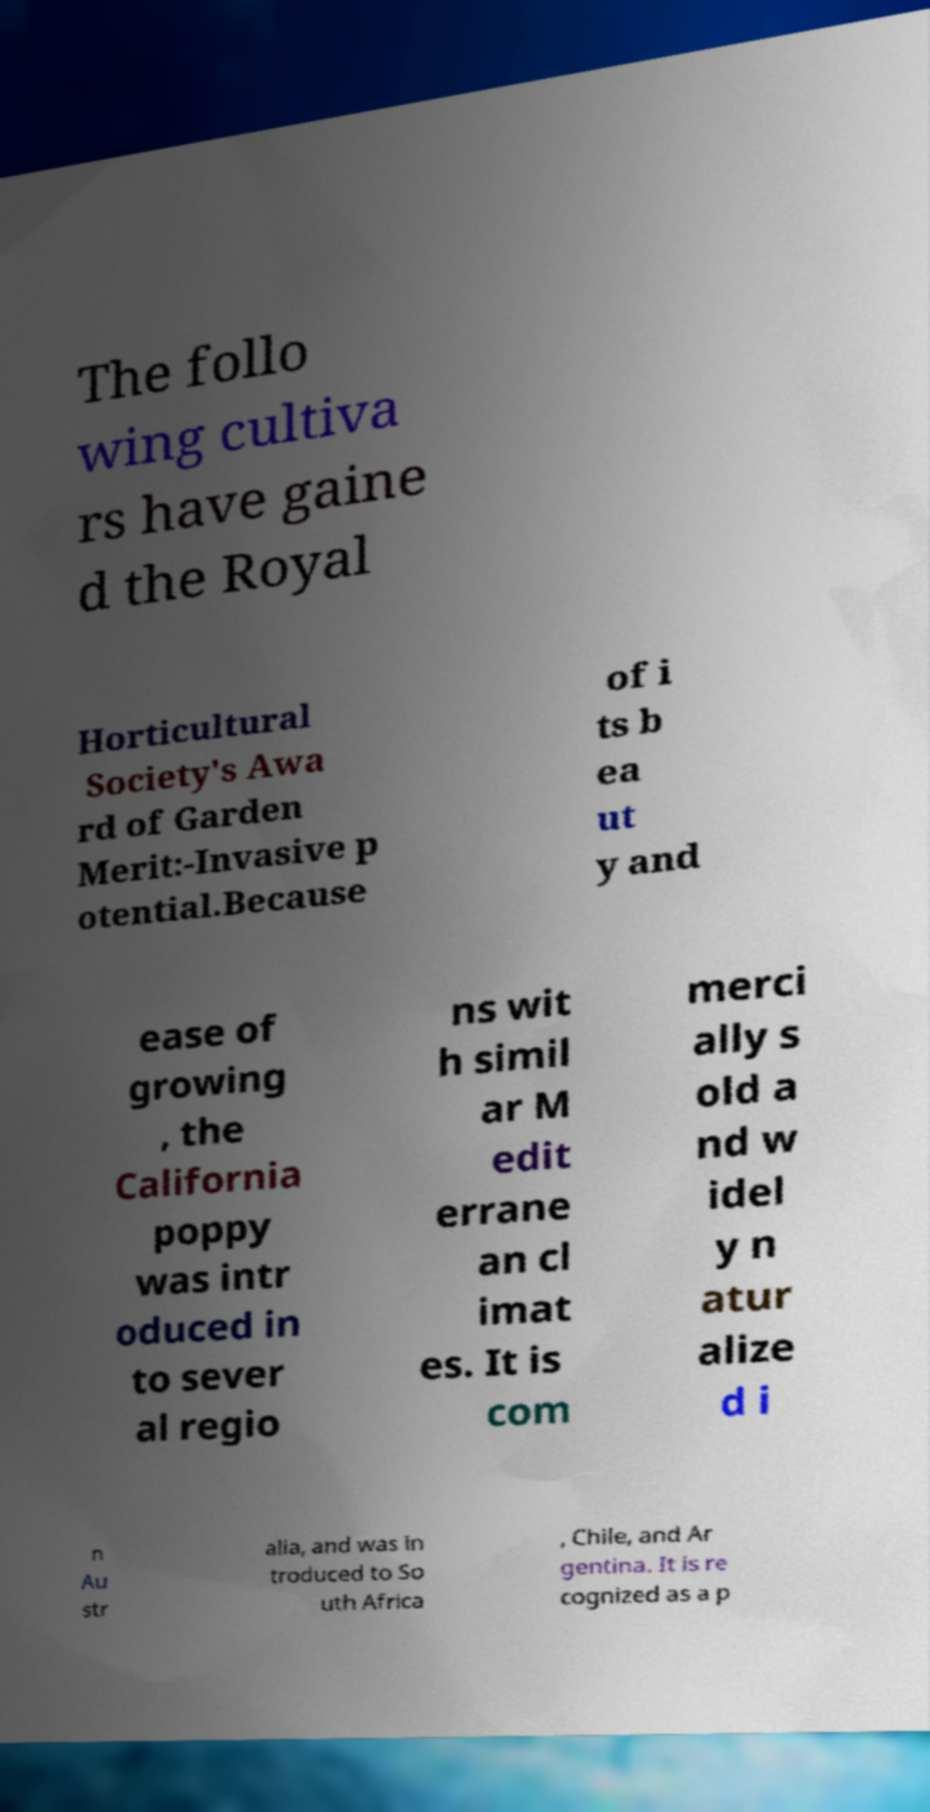Please read and relay the text visible in this image. What does it say? The follo wing cultiva rs have gaine d the Royal Horticultural Society's Awa rd of Garden Merit:-Invasive p otential.Because of i ts b ea ut y and ease of growing , the California poppy was intr oduced in to sever al regio ns wit h simil ar M edit errane an cl imat es. It is com merci ally s old a nd w idel y n atur alize d i n Au str alia, and was in troduced to So uth Africa , Chile, and Ar gentina. It is re cognized as a p 